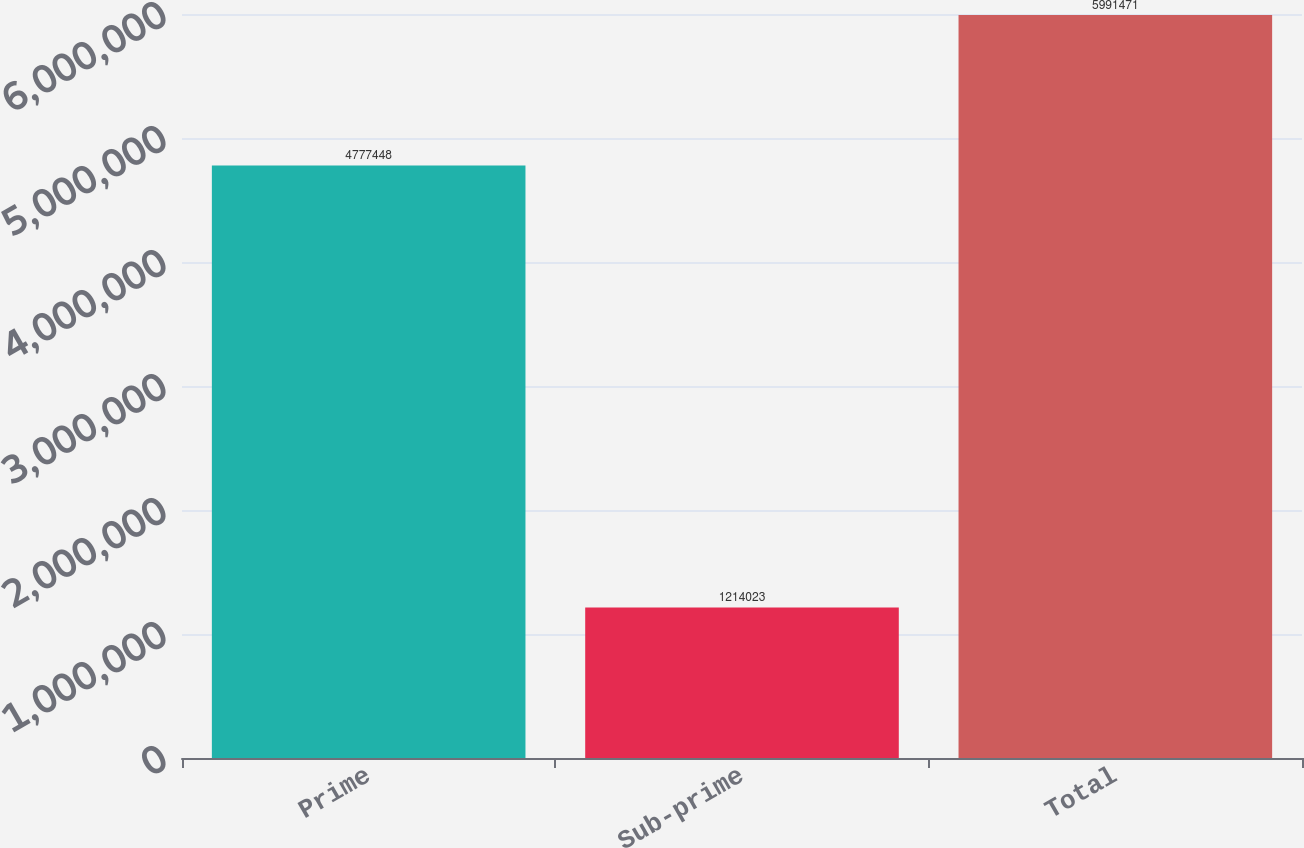<chart> <loc_0><loc_0><loc_500><loc_500><bar_chart><fcel>Prime<fcel>Sub-prime<fcel>Total<nl><fcel>4.77745e+06<fcel>1.21402e+06<fcel>5.99147e+06<nl></chart> 